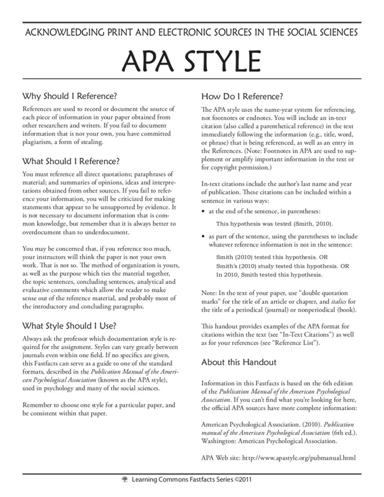Why is it essential to provide correct references in academic writing? Correct referencing in academic writing is crucial as it allows you to credit original authors for their ideas, prevents plagiarism, and lends greater credibility to your work. Proper references demonstrate careful and thorough scholarship and enable readers to follow or verify the research basis behind your arguments and assertions. 